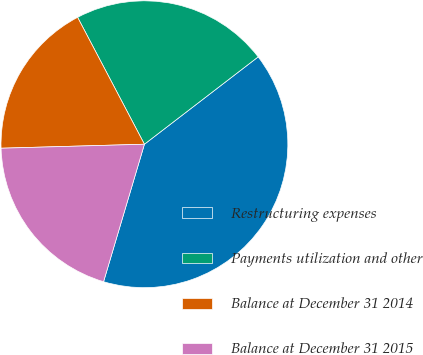<chart> <loc_0><loc_0><loc_500><loc_500><pie_chart><fcel>Restructuring expenses<fcel>Payments utilization and other<fcel>Balance at December 31 2014<fcel>Balance at December 31 2015<nl><fcel>40.02%<fcel>22.29%<fcel>17.73%<fcel>19.96%<nl></chart> 